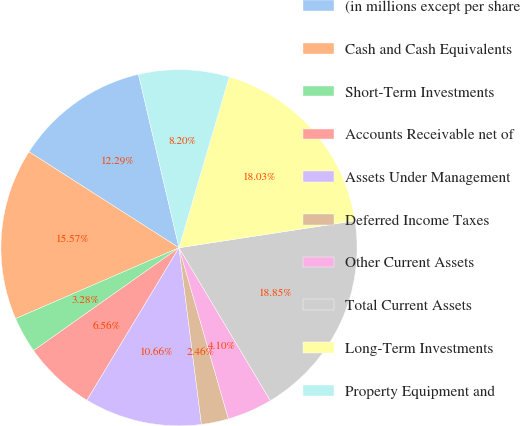Convert chart to OTSL. <chart><loc_0><loc_0><loc_500><loc_500><pie_chart><fcel>(in millions except per share<fcel>Cash and Cash Equivalents<fcel>Short-Term Investments<fcel>Accounts Receivable net of<fcel>Assets Under Management<fcel>Deferred Income Taxes<fcel>Other Current Assets<fcel>Total Current Assets<fcel>Long-Term Investments<fcel>Property Equipment and<nl><fcel>12.29%<fcel>15.57%<fcel>3.28%<fcel>6.56%<fcel>10.66%<fcel>2.46%<fcel>4.1%<fcel>18.85%<fcel>18.03%<fcel>8.2%<nl></chart> 